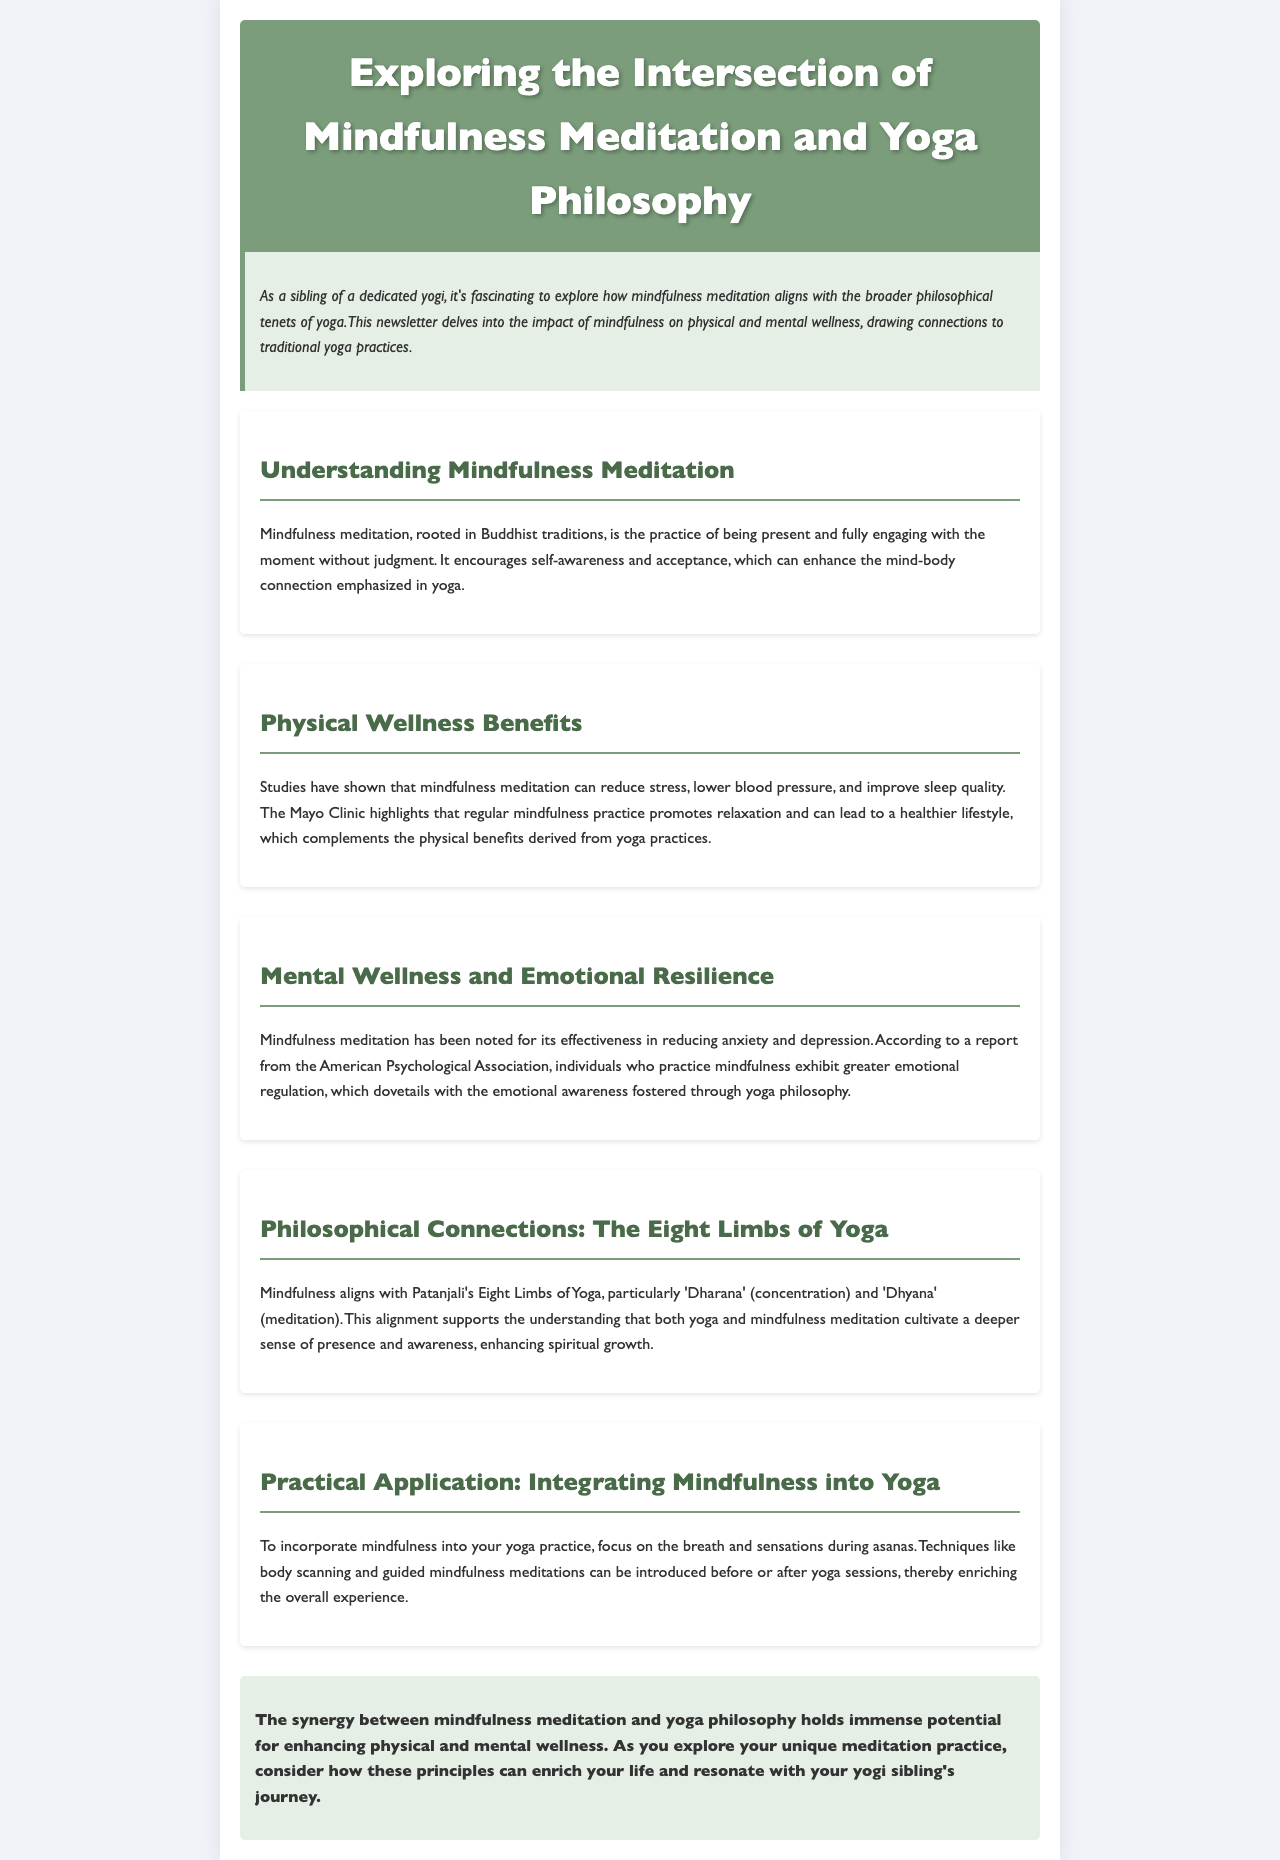what is the main focus of the newsletter? The newsletter centers around how mindfulness meditation impacts physical and mental wellness in the context of yoga philosophy.
Answer: mindfulness meditation and yoga philosophy who highlights the benefits of mindfulness meditation? The benefits of mindfulness meditation are highlighted by the Mayo Clinic in the document.
Answer: Mayo Clinic what are “Dharana” and “Dhyana”? “Dharana” and “Dhyana” are terms from Patanjali's Eight Limbs of Yoga that relate to concentration and meditation respectively.
Answer: concentration and meditation how can mindfulness be integrated into yoga practice? Mindfulness can be integrated by focusing on the breath and sensations during asanas or through techniques like body scanning.
Answer: focusing on breath and sensations what emotional aspect does mindfulness meditation help with according to the American Psychological Association? Mindfulness meditation helps with emotional regulation and reduces anxiety and depression.
Answer: emotional regulation 